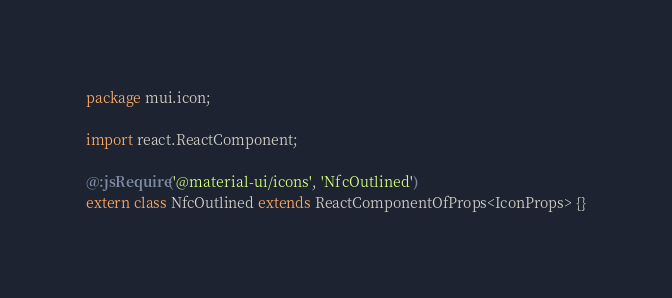<code> <loc_0><loc_0><loc_500><loc_500><_Haxe_>package mui.icon;

import react.ReactComponent;

@:jsRequire('@material-ui/icons', 'NfcOutlined')
extern class NfcOutlined extends ReactComponentOfProps<IconProps> {}
</code> 